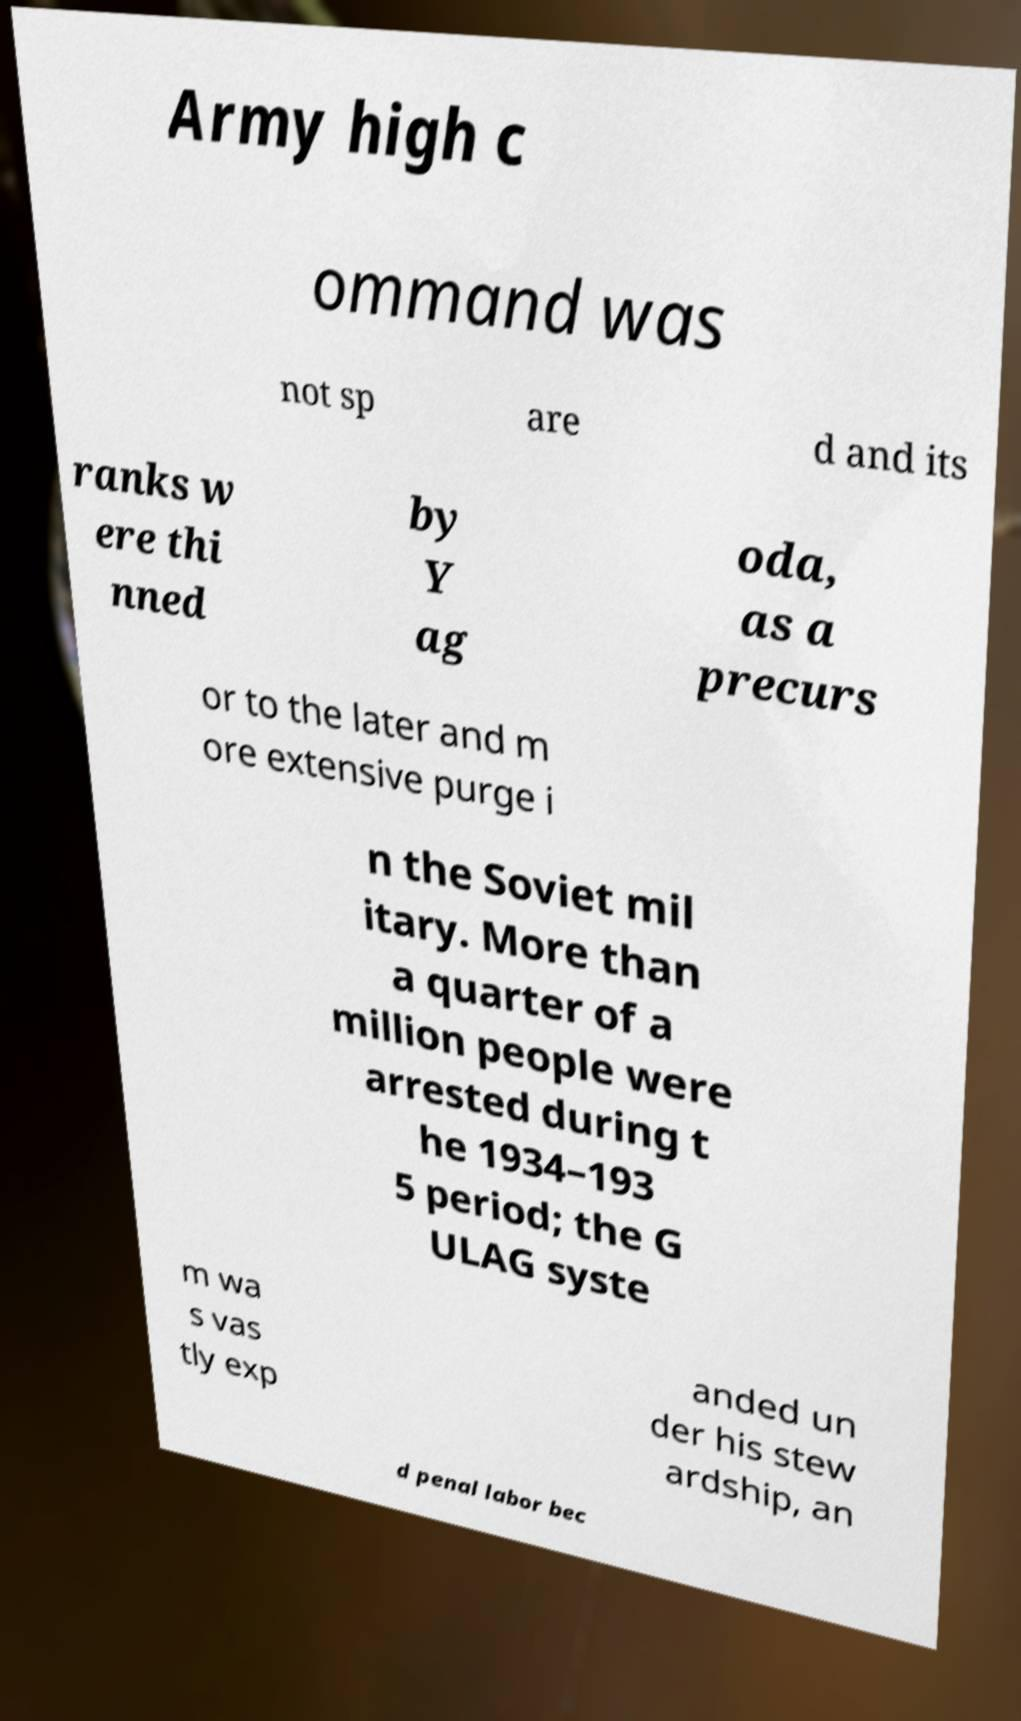For documentation purposes, I need the text within this image transcribed. Could you provide that? Army high c ommand was not sp are d and its ranks w ere thi nned by Y ag oda, as a precurs or to the later and m ore extensive purge i n the Soviet mil itary. More than a quarter of a million people were arrested during t he 1934–193 5 period; the G ULAG syste m wa s vas tly exp anded un der his stew ardship, an d penal labor bec 